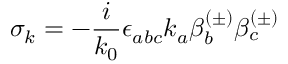Convert formula to latex. <formula><loc_0><loc_0><loc_500><loc_500>\sigma _ { k } = - \frac { i } k _ { 0 } } \epsilon _ { a b c } k _ { a } \beta _ { b } ^ { ( \pm ) } \beta _ { c } ^ { ( \pm ) }</formula> 